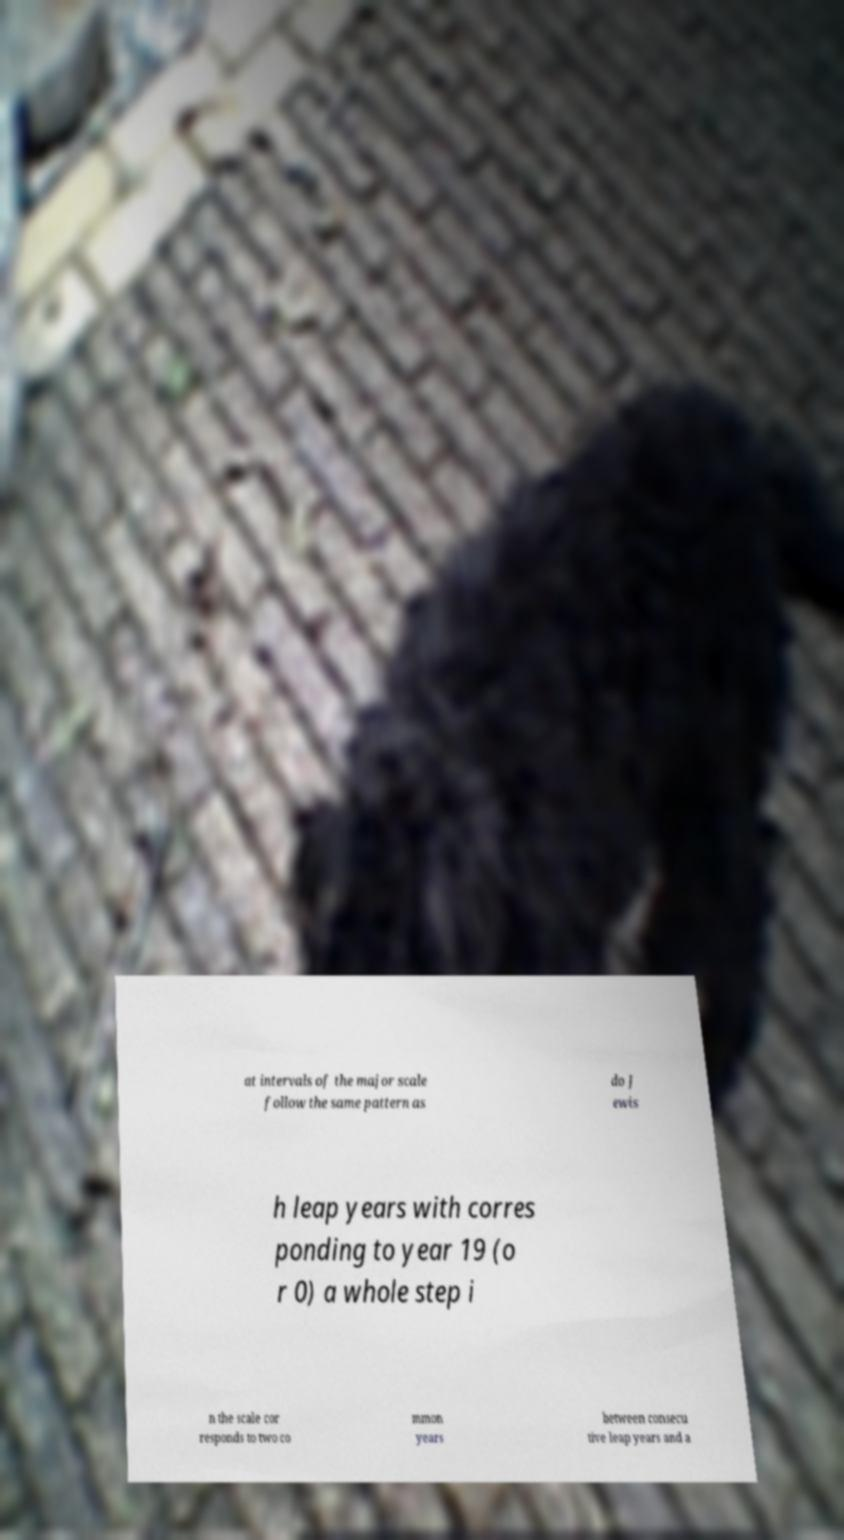Could you assist in decoding the text presented in this image and type it out clearly? at intervals of the major scale follow the same pattern as do J ewis h leap years with corres ponding to year 19 (o r 0) a whole step i n the scale cor responds to two co mmon years between consecu tive leap years and a 